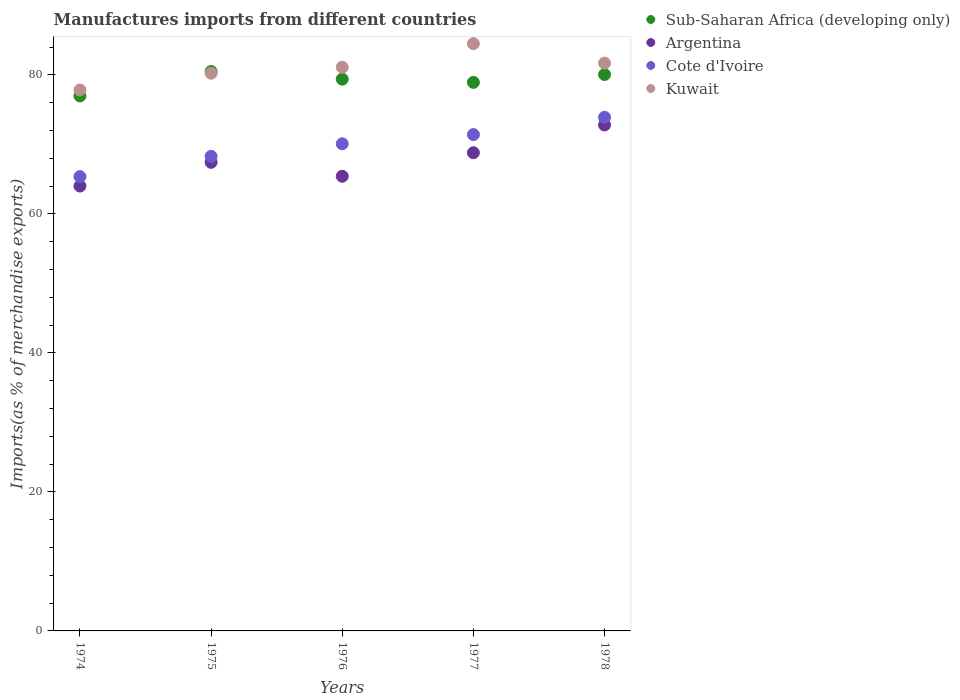How many different coloured dotlines are there?
Offer a very short reply. 4. Is the number of dotlines equal to the number of legend labels?
Provide a succinct answer. Yes. What is the percentage of imports to different countries in Kuwait in 1978?
Provide a short and direct response. 81.69. Across all years, what is the maximum percentage of imports to different countries in Cote d'Ivoire?
Offer a terse response. 73.9. Across all years, what is the minimum percentage of imports to different countries in Sub-Saharan Africa (developing only)?
Your response must be concise. 76.97. In which year was the percentage of imports to different countries in Cote d'Ivoire maximum?
Your answer should be very brief. 1978. In which year was the percentage of imports to different countries in Kuwait minimum?
Make the answer very short. 1974. What is the total percentage of imports to different countries in Sub-Saharan Africa (developing only) in the graph?
Offer a terse response. 395.81. What is the difference between the percentage of imports to different countries in Kuwait in 1975 and that in 1976?
Your response must be concise. -0.86. What is the difference between the percentage of imports to different countries in Sub-Saharan Africa (developing only) in 1975 and the percentage of imports to different countries in Kuwait in 1977?
Give a very brief answer. -4. What is the average percentage of imports to different countries in Sub-Saharan Africa (developing only) per year?
Ensure brevity in your answer.  79.16. In the year 1974, what is the difference between the percentage of imports to different countries in Kuwait and percentage of imports to different countries in Sub-Saharan Africa (developing only)?
Provide a succinct answer. 0.86. In how many years, is the percentage of imports to different countries in Cote d'Ivoire greater than 76 %?
Give a very brief answer. 0. What is the ratio of the percentage of imports to different countries in Sub-Saharan Africa (developing only) in 1975 to that in 1977?
Make the answer very short. 1.02. Is the difference between the percentage of imports to different countries in Kuwait in 1975 and 1977 greater than the difference between the percentage of imports to different countries in Sub-Saharan Africa (developing only) in 1975 and 1977?
Offer a terse response. No. What is the difference between the highest and the second highest percentage of imports to different countries in Kuwait?
Ensure brevity in your answer.  2.79. What is the difference between the highest and the lowest percentage of imports to different countries in Cote d'Ivoire?
Your answer should be very brief. 8.54. Is it the case that in every year, the sum of the percentage of imports to different countries in Argentina and percentage of imports to different countries in Sub-Saharan Africa (developing only)  is greater than the sum of percentage of imports to different countries in Kuwait and percentage of imports to different countries in Cote d'Ivoire?
Provide a succinct answer. No. Is it the case that in every year, the sum of the percentage of imports to different countries in Argentina and percentage of imports to different countries in Sub-Saharan Africa (developing only)  is greater than the percentage of imports to different countries in Cote d'Ivoire?
Your answer should be compact. Yes. Does the percentage of imports to different countries in Sub-Saharan Africa (developing only) monotonically increase over the years?
Keep it short and to the point. No. How many dotlines are there?
Your answer should be compact. 4. How many years are there in the graph?
Offer a terse response. 5. Does the graph contain any zero values?
Give a very brief answer. No. Where does the legend appear in the graph?
Keep it short and to the point. Top right. How many legend labels are there?
Offer a terse response. 4. What is the title of the graph?
Give a very brief answer. Manufactures imports from different countries. Does "Myanmar" appear as one of the legend labels in the graph?
Provide a short and direct response. No. What is the label or title of the Y-axis?
Your response must be concise. Imports(as % of merchandise exports). What is the Imports(as % of merchandise exports) of Sub-Saharan Africa (developing only) in 1974?
Keep it short and to the point. 76.97. What is the Imports(as % of merchandise exports) in Argentina in 1974?
Keep it short and to the point. 64. What is the Imports(as % of merchandise exports) in Cote d'Ivoire in 1974?
Provide a short and direct response. 65.36. What is the Imports(as % of merchandise exports) of Kuwait in 1974?
Your answer should be very brief. 77.82. What is the Imports(as % of merchandise exports) of Sub-Saharan Africa (developing only) in 1975?
Offer a very short reply. 80.48. What is the Imports(as % of merchandise exports) of Argentina in 1975?
Your response must be concise. 67.42. What is the Imports(as % of merchandise exports) of Cote d'Ivoire in 1975?
Provide a succinct answer. 68.27. What is the Imports(as % of merchandise exports) of Kuwait in 1975?
Your answer should be very brief. 80.24. What is the Imports(as % of merchandise exports) of Sub-Saharan Africa (developing only) in 1976?
Provide a short and direct response. 79.39. What is the Imports(as % of merchandise exports) of Argentina in 1976?
Offer a terse response. 65.42. What is the Imports(as % of merchandise exports) of Cote d'Ivoire in 1976?
Provide a short and direct response. 70.08. What is the Imports(as % of merchandise exports) in Kuwait in 1976?
Keep it short and to the point. 81.1. What is the Imports(as % of merchandise exports) in Sub-Saharan Africa (developing only) in 1977?
Your answer should be compact. 78.92. What is the Imports(as % of merchandise exports) of Argentina in 1977?
Your answer should be very brief. 68.8. What is the Imports(as % of merchandise exports) of Cote d'Ivoire in 1977?
Offer a terse response. 71.41. What is the Imports(as % of merchandise exports) in Kuwait in 1977?
Your answer should be compact. 84.49. What is the Imports(as % of merchandise exports) in Sub-Saharan Africa (developing only) in 1978?
Give a very brief answer. 80.05. What is the Imports(as % of merchandise exports) in Argentina in 1978?
Your answer should be very brief. 72.79. What is the Imports(as % of merchandise exports) of Cote d'Ivoire in 1978?
Provide a succinct answer. 73.9. What is the Imports(as % of merchandise exports) in Kuwait in 1978?
Offer a terse response. 81.69. Across all years, what is the maximum Imports(as % of merchandise exports) in Sub-Saharan Africa (developing only)?
Give a very brief answer. 80.48. Across all years, what is the maximum Imports(as % of merchandise exports) in Argentina?
Provide a short and direct response. 72.79. Across all years, what is the maximum Imports(as % of merchandise exports) of Cote d'Ivoire?
Provide a succinct answer. 73.9. Across all years, what is the maximum Imports(as % of merchandise exports) of Kuwait?
Give a very brief answer. 84.49. Across all years, what is the minimum Imports(as % of merchandise exports) of Sub-Saharan Africa (developing only)?
Ensure brevity in your answer.  76.97. Across all years, what is the minimum Imports(as % of merchandise exports) in Argentina?
Your answer should be very brief. 64. Across all years, what is the minimum Imports(as % of merchandise exports) of Cote d'Ivoire?
Ensure brevity in your answer.  65.36. Across all years, what is the minimum Imports(as % of merchandise exports) of Kuwait?
Offer a terse response. 77.82. What is the total Imports(as % of merchandise exports) of Sub-Saharan Africa (developing only) in the graph?
Provide a short and direct response. 395.81. What is the total Imports(as % of merchandise exports) of Argentina in the graph?
Your response must be concise. 338.43. What is the total Imports(as % of merchandise exports) in Cote d'Ivoire in the graph?
Make the answer very short. 349.02. What is the total Imports(as % of merchandise exports) of Kuwait in the graph?
Your answer should be very brief. 405.34. What is the difference between the Imports(as % of merchandise exports) of Sub-Saharan Africa (developing only) in 1974 and that in 1975?
Your answer should be compact. -3.52. What is the difference between the Imports(as % of merchandise exports) of Argentina in 1974 and that in 1975?
Provide a succinct answer. -3.42. What is the difference between the Imports(as % of merchandise exports) of Cote d'Ivoire in 1974 and that in 1975?
Ensure brevity in your answer.  -2.92. What is the difference between the Imports(as % of merchandise exports) in Kuwait in 1974 and that in 1975?
Keep it short and to the point. -2.41. What is the difference between the Imports(as % of merchandise exports) of Sub-Saharan Africa (developing only) in 1974 and that in 1976?
Keep it short and to the point. -2.42. What is the difference between the Imports(as % of merchandise exports) of Argentina in 1974 and that in 1976?
Your answer should be compact. -1.41. What is the difference between the Imports(as % of merchandise exports) in Cote d'Ivoire in 1974 and that in 1976?
Keep it short and to the point. -4.73. What is the difference between the Imports(as % of merchandise exports) in Kuwait in 1974 and that in 1976?
Your answer should be compact. -3.27. What is the difference between the Imports(as % of merchandise exports) in Sub-Saharan Africa (developing only) in 1974 and that in 1977?
Your answer should be compact. -1.95. What is the difference between the Imports(as % of merchandise exports) of Argentina in 1974 and that in 1977?
Offer a terse response. -4.8. What is the difference between the Imports(as % of merchandise exports) of Cote d'Ivoire in 1974 and that in 1977?
Your answer should be very brief. -6.05. What is the difference between the Imports(as % of merchandise exports) of Kuwait in 1974 and that in 1977?
Provide a short and direct response. -6.66. What is the difference between the Imports(as % of merchandise exports) in Sub-Saharan Africa (developing only) in 1974 and that in 1978?
Your answer should be compact. -3.08. What is the difference between the Imports(as % of merchandise exports) of Argentina in 1974 and that in 1978?
Offer a very short reply. -8.79. What is the difference between the Imports(as % of merchandise exports) in Cote d'Ivoire in 1974 and that in 1978?
Make the answer very short. -8.54. What is the difference between the Imports(as % of merchandise exports) of Kuwait in 1974 and that in 1978?
Provide a short and direct response. -3.87. What is the difference between the Imports(as % of merchandise exports) of Sub-Saharan Africa (developing only) in 1975 and that in 1976?
Give a very brief answer. 1.1. What is the difference between the Imports(as % of merchandise exports) of Argentina in 1975 and that in 1976?
Provide a short and direct response. 2. What is the difference between the Imports(as % of merchandise exports) of Cote d'Ivoire in 1975 and that in 1976?
Your answer should be very brief. -1.81. What is the difference between the Imports(as % of merchandise exports) in Kuwait in 1975 and that in 1976?
Offer a very short reply. -0.86. What is the difference between the Imports(as % of merchandise exports) of Sub-Saharan Africa (developing only) in 1975 and that in 1977?
Offer a terse response. 1.56. What is the difference between the Imports(as % of merchandise exports) of Argentina in 1975 and that in 1977?
Ensure brevity in your answer.  -1.38. What is the difference between the Imports(as % of merchandise exports) of Cote d'Ivoire in 1975 and that in 1977?
Ensure brevity in your answer.  -3.14. What is the difference between the Imports(as % of merchandise exports) in Kuwait in 1975 and that in 1977?
Offer a terse response. -4.25. What is the difference between the Imports(as % of merchandise exports) of Sub-Saharan Africa (developing only) in 1975 and that in 1978?
Provide a succinct answer. 0.43. What is the difference between the Imports(as % of merchandise exports) in Argentina in 1975 and that in 1978?
Ensure brevity in your answer.  -5.37. What is the difference between the Imports(as % of merchandise exports) of Cote d'Ivoire in 1975 and that in 1978?
Your response must be concise. -5.62. What is the difference between the Imports(as % of merchandise exports) in Kuwait in 1975 and that in 1978?
Offer a very short reply. -1.45. What is the difference between the Imports(as % of merchandise exports) of Sub-Saharan Africa (developing only) in 1976 and that in 1977?
Your answer should be very brief. 0.47. What is the difference between the Imports(as % of merchandise exports) in Argentina in 1976 and that in 1977?
Provide a short and direct response. -3.38. What is the difference between the Imports(as % of merchandise exports) of Cote d'Ivoire in 1976 and that in 1977?
Ensure brevity in your answer.  -1.32. What is the difference between the Imports(as % of merchandise exports) in Kuwait in 1976 and that in 1977?
Offer a very short reply. -3.39. What is the difference between the Imports(as % of merchandise exports) in Sub-Saharan Africa (developing only) in 1976 and that in 1978?
Ensure brevity in your answer.  -0.67. What is the difference between the Imports(as % of merchandise exports) in Argentina in 1976 and that in 1978?
Ensure brevity in your answer.  -7.38. What is the difference between the Imports(as % of merchandise exports) in Cote d'Ivoire in 1976 and that in 1978?
Provide a succinct answer. -3.81. What is the difference between the Imports(as % of merchandise exports) in Kuwait in 1976 and that in 1978?
Your answer should be very brief. -0.6. What is the difference between the Imports(as % of merchandise exports) of Sub-Saharan Africa (developing only) in 1977 and that in 1978?
Provide a short and direct response. -1.13. What is the difference between the Imports(as % of merchandise exports) in Argentina in 1977 and that in 1978?
Offer a terse response. -3.99. What is the difference between the Imports(as % of merchandise exports) of Cote d'Ivoire in 1977 and that in 1978?
Give a very brief answer. -2.49. What is the difference between the Imports(as % of merchandise exports) of Kuwait in 1977 and that in 1978?
Provide a succinct answer. 2.79. What is the difference between the Imports(as % of merchandise exports) of Sub-Saharan Africa (developing only) in 1974 and the Imports(as % of merchandise exports) of Argentina in 1975?
Keep it short and to the point. 9.55. What is the difference between the Imports(as % of merchandise exports) in Sub-Saharan Africa (developing only) in 1974 and the Imports(as % of merchandise exports) in Cote d'Ivoire in 1975?
Make the answer very short. 8.69. What is the difference between the Imports(as % of merchandise exports) in Sub-Saharan Africa (developing only) in 1974 and the Imports(as % of merchandise exports) in Kuwait in 1975?
Offer a terse response. -3.27. What is the difference between the Imports(as % of merchandise exports) in Argentina in 1974 and the Imports(as % of merchandise exports) in Cote d'Ivoire in 1975?
Give a very brief answer. -4.27. What is the difference between the Imports(as % of merchandise exports) in Argentina in 1974 and the Imports(as % of merchandise exports) in Kuwait in 1975?
Offer a very short reply. -16.23. What is the difference between the Imports(as % of merchandise exports) in Cote d'Ivoire in 1974 and the Imports(as % of merchandise exports) in Kuwait in 1975?
Offer a terse response. -14.88. What is the difference between the Imports(as % of merchandise exports) of Sub-Saharan Africa (developing only) in 1974 and the Imports(as % of merchandise exports) of Argentina in 1976?
Your response must be concise. 11.55. What is the difference between the Imports(as % of merchandise exports) in Sub-Saharan Africa (developing only) in 1974 and the Imports(as % of merchandise exports) in Cote d'Ivoire in 1976?
Your answer should be very brief. 6.88. What is the difference between the Imports(as % of merchandise exports) in Sub-Saharan Africa (developing only) in 1974 and the Imports(as % of merchandise exports) in Kuwait in 1976?
Give a very brief answer. -4.13. What is the difference between the Imports(as % of merchandise exports) in Argentina in 1974 and the Imports(as % of merchandise exports) in Cote d'Ivoire in 1976?
Offer a very short reply. -6.08. What is the difference between the Imports(as % of merchandise exports) in Argentina in 1974 and the Imports(as % of merchandise exports) in Kuwait in 1976?
Give a very brief answer. -17.09. What is the difference between the Imports(as % of merchandise exports) of Cote d'Ivoire in 1974 and the Imports(as % of merchandise exports) of Kuwait in 1976?
Offer a very short reply. -15.74. What is the difference between the Imports(as % of merchandise exports) in Sub-Saharan Africa (developing only) in 1974 and the Imports(as % of merchandise exports) in Argentina in 1977?
Your answer should be compact. 8.17. What is the difference between the Imports(as % of merchandise exports) of Sub-Saharan Africa (developing only) in 1974 and the Imports(as % of merchandise exports) of Cote d'Ivoire in 1977?
Your answer should be compact. 5.56. What is the difference between the Imports(as % of merchandise exports) in Sub-Saharan Africa (developing only) in 1974 and the Imports(as % of merchandise exports) in Kuwait in 1977?
Provide a succinct answer. -7.52. What is the difference between the Imports(as % of merchandise exports) of Argentina in 1974 and the Imports(as % of merchandise exports) of Cote d'Ivoire in 1977?
Keep it short and to the point. -7.41. What is the difference between the Imports(as % of merchandise exports) of Argentina in 1974 and the Imports(as % of merchandise exports) of Kuwait in 1977?
Offer a very short reply. -20.48. What is the difference between the Imports(as % of merchandise exports) in Cote d'Ivoire in 1974 and the Imports(as % of merchandise exports) in Kuwait in 1977?
Your answer should be compact. -19.13. What is the difference between the Imports(as % of merchandise exports) of Sub-Saharan Africa (developing only) in 1974 and the Imports(as % of merchandise exports) of Argentina in 1978?
Keep it short and to the point. 4.17. What is the difference between the Imports(as % of merchandise exports) of Sub-Saharan Africa (developing only) in 1974 and the Imports(as % of merchandise exports) of Cote d'Ivoire in 1978?
Provide a succinct answer. 3.07. What is the difference between the Imports(as % of merchandise exports) in Sub-Saharan Africa (developing only) in 1974 and the Imports(as % of merchandise exports) in Kuwait in 1978?
Provide a succinct answer. -4.72. What is the difference between the Imports(as % of merchandise exports) of Argentina in 1974 and the Imports(as % of merchandise exports) of Cote d'Ivoire in 1978?
Offer a terse response. -9.89. What is the difference between the Imports(as % of merchandise exports) in Argentina in 1974 and the Imports(as % of merchandise exports) in Kuwait in 1978?
Give a very brief answer. -17.69. What is the difference between the Imports(as % of merchandise exports) in Cote d'Ivoire in 1974 and the Imports(as % of merchandise exports) in Kuwait in 1978?
Your answer should be very brief. -16.33. What is the difference between the Imports(as % of merchandise exports) in Sub-Saharan Africa (developing only) in 1975 and the Imports(as % of merchandise exports) in Argentina in 1976?
Make the answer very short. 15.07. What is the difference between the Imports(as % of merchandise exports) in Sub-Saharan Africa (developing only) in 1975 and the Imports(as % of merchandise exports) in Cote d'Ivoire in 1976?
Your answer should be compact. 10.4. What is the difference between the Imports(as % of merchandise exports) in Sub-Saharan Africa (developing only) in 1975 and the Imports(as % of merchandise exports) in Kuwait in 1976?
Your response must be concise. -0.61. What is the difference between the Imports(as % of merchandise exports) of Argentina in 1975 and the Imports(as % of merchandise exports) of Cote d'Ivoire in 1976?
Provide a short and direct response. -2.67. What is the difference between the Imports(as % of merchandise exports) of Argentina in 1975 and the Imports(as % of merchandise exports) of Kuwait in 1976?
Ensure brevity in your answer.  -13.68. What is the difference between the Imports(as % of merchandise exports) of Cote d'Ivoire in 1975 and the Imports(as % of merchandise exports) of Kuwait in 1976?
Ensure brevity in your answer.  -12.82. What is the difference between the Imports(as % of merchandise exports) in Sub-Saharan Africa (developing only) in 1975 and the Imports(as % of merchandise exports) in Argentina in 1977?
Your answer should be very brief. 11.69. What is the difference between the Imports(as % of merchandise exports) in Sub-Saharan Africa (developing only) in 1975 and the Imports(as % of merchandise exports) in Cote d'Ivoire in 1977?
Your answer should be compact. 9.08. What is the difference between the Imports(as % of merchandise exports) of Sub-Saharan Africa (developing only) in 1975 and the Imports(as % of merchandise exports) of Kuwait in 1977?
Your response must be concise. -4. What is the difference between the Imports(as % of merchandise exports) of Argentina in 1975 and the Imports(as % of merchandise exports) of Cote d'Ivoire in 1977?
Your response must be concise. -3.99. What is the difference between the Imports(as % of merchandise exports) in Argentina in 1975 and the Imports(as % of merchandise exports) in Kuwait in 1977?
Your response must be concise. -17.07. What is the difference between the Imports(as % of merchandise exports) of Cote d'Ivoire in 1975 and the Imports(as % of merchandise exports) of Kuwait in 1977?
Make the answer very short. -16.21. What is the difference between the Imports(as % of merchandise exports) in Sub-Saharan Africa (developing only) in 1975 and the Imports(as % of merchandise exports) in Argentina in 1978?
Make the answer very short. 7.69. What is the difference between the Imports(as % of merchandise exports) in Sub-Saharan Africa (developing only) in 1975 and the Imports(as % of merchandise exports) in Cote d'Ivoire in 1978?
Give a very brief answer. 6.59. What is the difference between the Imports(as % of merchandise exports) in Sub-Saharan Africa (developing only) in 1975 and the Imports(as % of merchandise exports) in Kuwait in 1978?
Make the answer very short. -1.21. What is the difference between the Imports(as % of merchandise exports) in Argentina in 1975 and the Imports(as % of merchandise exports) in Cote d'Ivoire in 1978?
Offer a terse response. -6.48. What is the difference between the Imports(as % of merchandise exports) of Argentina in 1975 and the Imports(as % of merchandise exports) of Kuwait in 1978?
Offer a terse response. -14.27. What is the difference between the Imports(as % of merchandise exports) of Cote d'Ivoire in 1975 and the Imports(as % of merchandise exports) of Kuwait in 1978?
Provide a succinct answer. -13.42. What is the difference between the Imports(as % of merchandise exports) of Sub-Saharan Africa (developing only) in 1976 and the Imports(as % of merchandise exports) of Argentina in 1977?
Your answer should be very brief. 10.59. What is the difference between the Imports(as % of merchandise exports) in Sub-Saharan Africa (developing only) in 1976 and the Imports(as % of merchandise exports) in Cote d'Ivoire in 1977?
Keep it short and to the point. 7.98. What is the difference between the Imports(as % of merchandise exports) in Sub-Saharan Africa (developing only) in 1976 and the Imports(as % of merchandise exports) in Kuwait in 1977?
Provide a short and direct response. -5.1. What is the difference between the Imports(as % of merchandise exports) of Argentina in 1976 and the Imports(as % of merchandise exports) of Cote d'Ivoire in 1977?
Keep it short and to the point. -5.99. What is the difference between the Imports(as % of merchandise exports) of Argentina in 1976 and the Imports(as % of merchandise exports) of Kuwait in 1977?
Your answer should be compact. -19.07. What is the difference between the Imports(as % of merchandise exports) of Cote d'Ivoire in 1976 and the Imports(as % of merchandise exports) of Kuwait in 1977?
Ensure brevity in your answer.  -14.4. What is the difference between the Imports(as % of merchandise exports) of Sub-Saharan Africa (developing only) in 1976 and the Imports(as % of merchandise exports) of Argentina in 1978?
Your answer should be very brief. 6.59. What is the difference between the Imports(as % of merchandise exports) in Sub-Saharan Africa (developing only) in 1976 and the Imports(as % of merchandise exports) in Cote d'Ivoire in 1978?
Ensure brevity in your answer.  5.49. What is the difference between the Imports(as % of merchandise exports) of Sub-Saharan Africa (developing only) in 1976 and the Imports(as % of merchandise exports) of Kuwait in 1978?
Your response must be concise. -2.31. What is the difference between the Imports(as % of merchandise exports) of Argentina in 1976 and the Imports(as % of merchandise exports) of Cote d'Ivoire in 1978?
Provide a succinct answer. -8.48. What is the difference between the Imports(as % of merchandise exports) of Argentina in 1976 and the Imports(as % of merchandise exports) of Kuwait in 1978?
Your answer should be very brief. -16.28. What is the difference between the Imports(as % of merchandise exports) of Cote d'Ivoire in 1976 and the Imports(as % of merchandise exports) of Kuwait in 1978?
Give a very brief answer. -11.61. What is the difference between the Imports(as % of merchandise exports) of Sub-Saharan Africa (developing only) in 1977 and the Imports(as % of merchandise exports) of Argentina in 1978?
Your response must be concise. 6.13. What is the difference between the Imports(as % of merchandise exports) in Sub-Saharan Africa (developing only) in 1977 and the Imports(as % of merchandise exports) in Cote d'Ivoire in 1978?
Ensure brevity in your answer.  5.02. What is the difference between the Imports(as % of merchandise exports) in Sub-Saharan Africa (developing only) in 1977 and the Imports(as % of merchandise exports) in Kuwait in 1978?
Provide a succinct answer. -2.77. What is the difference between the Imports(as % of merchandise exports) of Argentina in 1977 and the Imports(as % of merchandise exports) of Cote d'Ivoire in 1978?
Make the answer very short. -5.1. What is the difference between the Imports(as % of merchandise exports) in Argentina in 1977 and the Imports(as % of merchandise exports) in Kuwait in 1978?
Make the answer very short. -12.89. What is the difference between the Imports(as % of merchandise exports) of Cote d'Ivoire in 1977 and the Imports(as % of merchandise exports) of Kuwait in 1978?
Your answer should be very brief. -10.28. What is the average Imports(as % of merchandise exports) in Sub-Saharan Africa (developing only) per year?
Make the answer very short. 79.16. What is the average Imports(as % of merchandise exports) of Argentina per year?
Make the answer very short. 67.69. What is the average Imports(as % of merchandise exports) in Cote d'Ivoire per year?
Your answer should be compact. 69.8. What is the average Imports(as % of merchandise exports) in Kuwait per year?
Offer a very short reply. 81.07. In the year 1974, what is the difference between the Imports(as % of merchandise exports) of Sub-Saharan Africa (developing only) and Imports(as % of merchandise exports) of Argentina?
Your answer should be compact. 12.96. In the year 1974, what is the difference between the Imports(as % of merchandise exports) of Sub-Saharan Africa (developing only) and Imports(as % of merchandise exports) of Cote d'Ivoire?
Provide a short and direct response. 11.61. In the year 1974, what is the difference between the Imports(as % of merchandise exports) in Sub-Saharan Africa (developing only) and Imports(as % of merchandise exports) in Kuwait?
Your response must be concise. -0.86. In the year 1974, what is the difference between the Imports(as % of merchandise exports) in Argentina and Imports(as % of merchandise exports) in Cote d'Ivoire?
Ensure brevity in your answer.  -1.35. In the year 1974, what is the difference between the Imports(as % of merchandise exports) of Argentina and Imports(as % of merchandise exports) of Kuwait?
Make the answer very short. -13.82. In the year 1974, what is the difference between the Imports(as % of merchandise exports) in Cote d'Ivoire and Imports(as % of merchandise exports) in Kuwait?
Your response must be concise. -12.47. In the year 1975, what is the difference between the Imports(as % of merchandise exports) of Sub-Saharan Africa (developing only) and Imports(as % of merchandise exports) of Argentina?
Offer a terse response. 13.07. In the year 1975, what is the difference between the Imports(as % of merchandise exports) in Sub-Saharan Africa (developing only) and Imports(as % of merchandise exports) in Cote d'Ivoire?
Keep it short and to the point. 12.21. In the year 1975, what is the difference between the Imports(as % of merchandise exports) in Sub-Saharan Africa (developing only) and Imports(as % of merchandise exports) in Kuwait?
Provide a short and direct response. 0.25. In the year 1975, what is the difference between the Imports(as % of merchandise exports) of Argentina and Imports(as % of merchandise exports) of Cote d'Ivoire?
Your answer should be very brief. -0.86. In the year 1975, what is the difference between the Imports(as % of merchandise exports) in Argentina and Imports(as % of merchandise exports) in Kuwait?
Make the answer very short. -12.82. In the year 1975, what is the difference between the Imports(as % of merchandise exports) of Cote d'Ivoire and Imports(as % of merchandise exports) of Kuwait?
Ensure brevity in your answer.  -11.96. In the year 1976, what is the difference between the Imports(as % of merchandise exports) in Sub-Saharan Africa (developing only) and Imports(as % of merchandise exports) in Argentina?
Keep it short and to the point. 13.97. In the year 1976, what is the difference between the Imports(as % of merchandise exports) in Sub-Saharan Africa (developing only) and Imports(as % of merchandise exports) in Cote d'Ivoire?
Provide a short and direct response. 9.3. In the year 1976, what is the difference between the Imports(as % of merchandise exports) of Sub-Saharan Africa (developing only) and Imports(as % of merchandise exports) of Kuwait?
Your response must be concise. -1.71. In the year 1976, what is the difference between the Imports(as % of merchandise exports) of Argentina and Imports(as % of merchandise exports) of Cote d'Ivoire?
Offer a terse response. -4.67. In the year 1976, what is the difference between the Imports(as % of merchandise exports) in Argentina and Imports(as % of merchandise exports) in Kuwait?
Provide a short and direct response. -15.68. In the year 1976, what is the difference between the Imports(as % of merchandise exports) in Cote d'Ivoire and Imports(as % of merchandise exports) in Kuwait?
Your answer should be compact. -11.01. In the year 1977, what is the difference between the Imports(as % of merchandise exports) in Sub-Saharan Africa (developing only) and Imports(as % of merchandise exports) in Argentina?
Your answer should be compact. 10.12. In the year 1977, what is the difference between the Imports(as % of merchandise exports) in Sub-Saharan Africa (developing only) and Imports(as % of merchandise exports) in Cote d'Ivoire?
Make the answer very short. 7.51. In the year 1977, what is the difference between the Imports(as % of merchandise exports) of Sub-Saharan Africa (developing only) and Imports(as % of merchandise exports) of Kuwait?
Provide a short and direct response. -5.57. In the year 1977, what is the difference between the Imports(as % of merchandise exports) of Argentina and Imports(as % of merchandise exports) of Cote d'Ivoire?
Make the answer very short. -2.61. In the year 1977, what is the difference between the Imports(as % of merchandise exports) of Argentina and Imports(as % of merchandise exports) of Kuwait?
Offer a very short reply. -15.69. In the year 1977, what is the difference between the Imports(as % of merchandise exports) of Cote d'Ivoire and Imports(as % of merchandise exports) of Kuwait?
Your answer should be very brief. -13.08. In the year 1978, what is the difference between the Imports(as % of merchandise exports) of Sub-Saharan Africa (developing only) and Imports(as % of merchandise exports) of Argentina?
Provide a short and direct response. 7.26. In the year 1978, what is the difference between the Imports(as % of merchandise exports) in Sub-Saharan Africa (developing only) and Imports(as % of merchandise exports) in Cote d'Ivoire?
Give a very brief answer. 6.15. In the year 1978, what is the difference between the Imports(as % of merchandise exports) of Sub-Saharan Africa (developing only) and Imports(as % of merchandise exports) of Kuwait?
Offer a very short reply. -1.64. In the year 1978, what is the difference between the Imports(as % of merchandise exports) of Argentina and Imports(as % of merchandise exports) of Cote d'Ivoire?
Your answer should be very brief. -1.1. In the year 1978, what is the difference between the Imports(as % of merchandise exports) of Argentina and Imports(as % of merchandise exports) of Kuwait?
Give a very brief answer. -8.9. In the year 1978, what is the difference between the Imports(as % of merchandise exports) in Cote d'Ivoire and Imports(as % of merchandise exports) in Kuwait?
Your answer should be compact. -7.79. What is the ratio of the Imports(as % of merchandise exports) in Sub-Saharan Africa (developing only) in 1974 to that in 1975?
Your answer should be compact. 0.96. What is the ratio of the Imports(as % of merchandise exports) of Argentina in 1974 to that in 1975?
Keep it short and to the point. 0.95. What is the ratio of the Imports(as % of merchandise exports) of Cote d'Ivoire in 1974 to that in 1975?
Make the answer very short. 0.96. What is the ratio of the Imports(as % of merchandise exports) in Kuwait in 1974 to that in 1975?
Keep it short and to the point. 0.97. What is the ratio of the Imports(as % of merchandise exports) in Sub-Saharan Africa (developing only) in 1974 to that in 1976?
Provide a short and direct response. 0.97. What is the ratio of the Imports(as % of merchandise exports) of Argentina in 1974 to that in 1976?
Provide a succinct answer. 0.98. What is the ratio of the Imports(as % of merchandise exports) in Cote d'Ivoire in 1974 to that in 1976?
Provide a succinct answer. 0.93. What is the ratio of the Imports(as % of merchandise exports) of Kuwait in 1974 to that in 1976?
Keep it short and to the point. 0.96. What is the ratio of the Imports(as % of merchandise exports) of Sub-Saharan Africa (developing only) in 1974 to that in 1977?
Keep it short and to the point. 0.98. What is the ratio of the Imports(as % of merchandise exports) of Argentina in 1974 to that in 1977?
Provide a succinct answer. 0.93. What is the ratio of the Imports(as % of merchandise exports) of Cote d'Ivoire in 1974 to that in 1977?
Ensure brevity in your answer.  0.92. What is the ratio of the Imports(as % of merchandise exports) of Kuwait in 1974 to that in 1977?
Your answer should be very brief. 0.92. What is the ratio of the Imports(as % of merchandise exports) of Sub-Saharan Africa (developing only) in 1974 to that in 1978?
Keep it short and to the point. 0.96. What is the ratio of the Imports(as % of merchandise exports) of Argentina in 1974 to that in 1978?
Your response must be concise. 0.88. What is the ratio of the Imports(as % of merchandise exports) of Cote d'Ivoire in 1974 to that in 1978?
Your answer should be compact. 0.88. What is the ratio of the Imports(as % of merchandise exports) of Kuwait in 1974 to that in 1978?
Your answer should be very brief. 0.95. What is the ratio of the Imports(as % of merchandise exports) of Sub-Saharan Africa (developing only) in 1975 to that in 1976?
Your answer should be compact. 1.01. What is the ratio of the Imports(as % of merchandise exports) in Argentina in 1975 to that in 1976?
Provide a short and direct response. 1.03. What is the ratio of the Imports(as % of merchandise exports) of Cote d'Ivoire in 1975 to that in 1976?
Provide a short and direct response. 0.97. What is the ratio of the Imports(as % of merchandise exports) of Kuwait in 1975 to that in 1976?
Give a very brief answer. 0.99. What is the ratio of the Imports(as % of merchandise exports) of Sub-Saharan Africa (developing only) in 1975 to that in 1977?
Keep it short and to the point. 1.02. What is the ratio of the Imports(as % of merchandise exports) in Argentina in 1975 to that in 1977?
Make the answer very short. 0.98. What is the ratio of the Imports(as % of merchandise exports) in Cote d'Ivoire in 1975 to that in 1977?
Your answer should be very brief. 0.96. What is the ratio of the Imports(as % of merchandise exports) in Kuwait in 1975 to that in 1977?
Ensure brevity in your answer.  0.95. What is the ratio of the Imports(as % of merchandise exports) of Sub-Saharan Africa (developing only) in 1975 to that in 1978?
Give a very brief answer. 1.01. What is the ratio of the Imports(as % of merchandise exports) of Argentina in 1975 to that in 1978?
Your answer should be compact. 0.93. What is the ratio of the Imports(as % of merchandise exports) of Cote d'Ivoire in 1975 to that in 1978?
Provide a short and direct response. 0.92. What is the ratio of the Imports(as % of merchandise exports) of Kuwait in 1975 to that in 1978?
Provide a succinct answer. 0.98. What is the ratio of the Imports(as % of merchandise exports) of Sub-Saharan Africa (developing only) in 1976 to that in 1977?
Give a very brief answer. 1.01. What is the ratio of the Imports(as % of merchandise exports) of Argentina in 1976 to that in 1977?
Offer a very short reply. 0.95. What is the ratio of the Imports(as % of merchandise exports) of Cote d'Ivoire in 1976 to that in 1977?
Your answer should be very brief. 0.98. What is the ratio of the Imports(as % of merchandise exports) of Kuwait in 1976 to that in 1977?
Your answer should be very brief. 0.96. What is the ratio of the Imports(as % of merchandise exports) of Argentina in 1976 to that in 1978?
Make the answer very short. 0.9. What is the ratio of the Imports(as % of merchandise exports) in Cote d'Ivoire in 1976 to that in 1978?
Give a very brief answer. 0.95. What is the ratio of the Imports(as % of merchandise exports) of Sub-Saharan Africa (developing only) in 1977 to that in 1978?
Your answer should be very brief. 0.99. What is the ratio of the Imports(as % of merchandise exports) of Argentina in 1977 to that in 1978?
Your response must be concise. 0.95. What is the ratio of the Imports(as % of merchandise exports) in Cote d'Ivoire in 1977 to that in 1978?
Offer a terse response. 0.97. What is the ratio of the Imports(as % of merchandise exports) in Kuwait in 1977 to that in 1978?
Offer a terse response. 1.03. What is the difference between the highest and the second highest Imports(as % of merchandise exports) in Sub-Saharan Africa (developing only)?
Make the answer very short. 0.43. What is the difference between the highest and the second highest Imports(as % of merchandise exports) in Argentina?
Keep it short and to the point. 3.99. What is the difference between the highest and the second highest Imports(as % of merchandise exports) of Cote d'Ivoire?
Give a very brief answer. 2.49. What is the difference between the highest and the second highest Imports(as % of merchandise exports) of Kuwait?
Provide a short and direct response. 2.79. What is the difference between the highest and the lowest Imports(as % of merchandise exports) of Sub-Saharan Africa (developing only)?
Provide a short and direct response. 3.52. What is the difference between the highest and the lowest Imports(as % of merchandise exports) of Argentina?
Keep it short and to the point. 8.79. What is the difference between the highest and the lowest Imports(as % of merchandise exports) of Cote d'Ivoire?
Keep it short and to the point. 8.54. What is the difference between the highest and the lowest Imports(as % of merchandise exports) in Kuwait?
Ensure brevity in your answer.  6.66. 